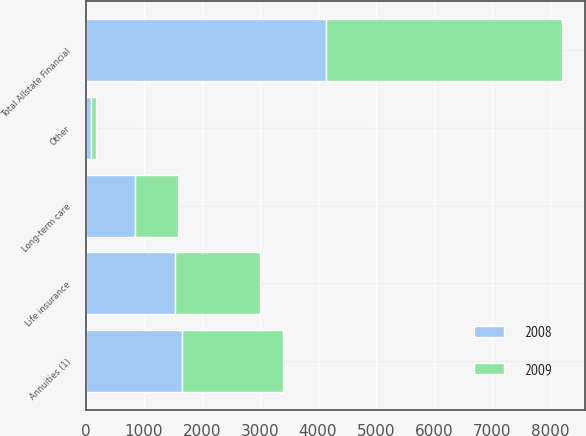Convert chart. <chart><loc_0><loc_0><loc_500><loc_500><stacked_bar_chart><ecel><fcel>Annuities (1)<fcel>Life insurance<fcel>Long-term care<fcel>Other<fcel>Total Allstate Financial<nl><fcel>2008<fcel>1667<fcel>1535<fcel>851<fcel>90<fcel>4143<nl><fcel>2009<fcel>1734<fcel>1475<fcel>746<fcel>96<fcel>4051<nl></chart> 